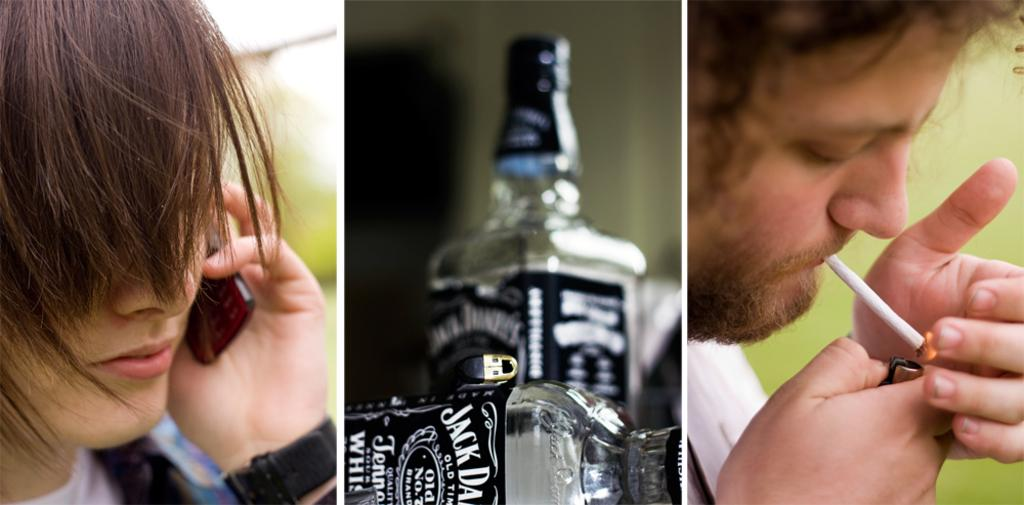Provide a one-sentence caption for the provided image. Collage of three pictures with two empty Jack Daniels bottles in the bottle. 